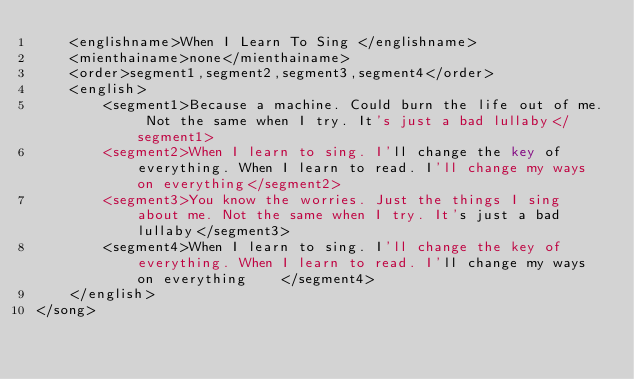<code> <loc_0><loc_0><loc_500><loc_500><_XML_>	<englishname>When I Learn To Sing </englishname>
	<mienthainame>none</mienthainame>
	<order>segment1,segment2,segment3,segment4</order>
	<english>
		<segment1>Because a machine. Could burn the life out of me. Not the same when I try. It's just a bad lullaby</segment1>
		<segment2>When I learn to sing. I'll change the key of everything. When I learn to read. I'll change my ways on everything</segment2>
		<segment3>You know the worries. Just the things I sing about me. Not the same when I try. It's just a bad lullaby</segment3>
		<segment4>When I learn to sing. I'll change the key of everything. When I learn to read. I'll change my ways on everything    </segment4>
	</english>
</song>
</code> 